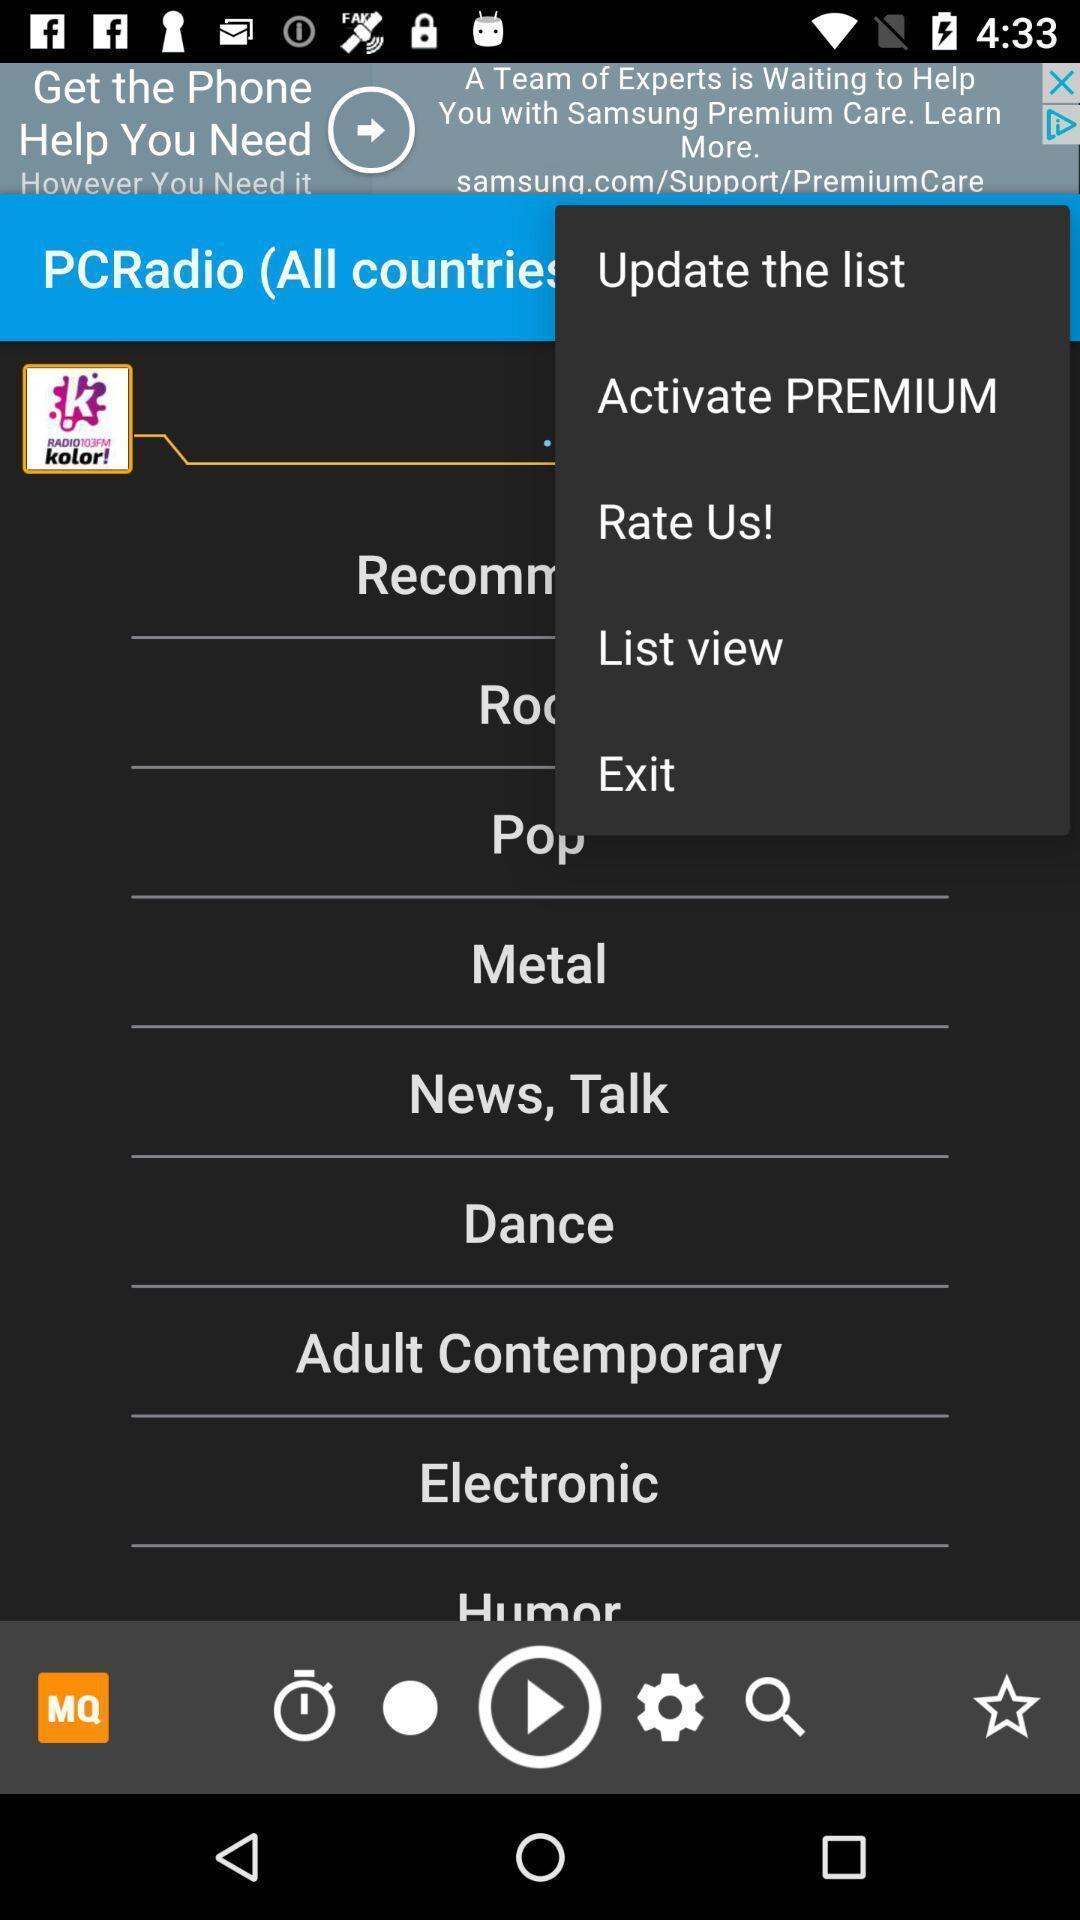Explain what's happening in this screen capture. Screen shows different options in an entertainment app. 